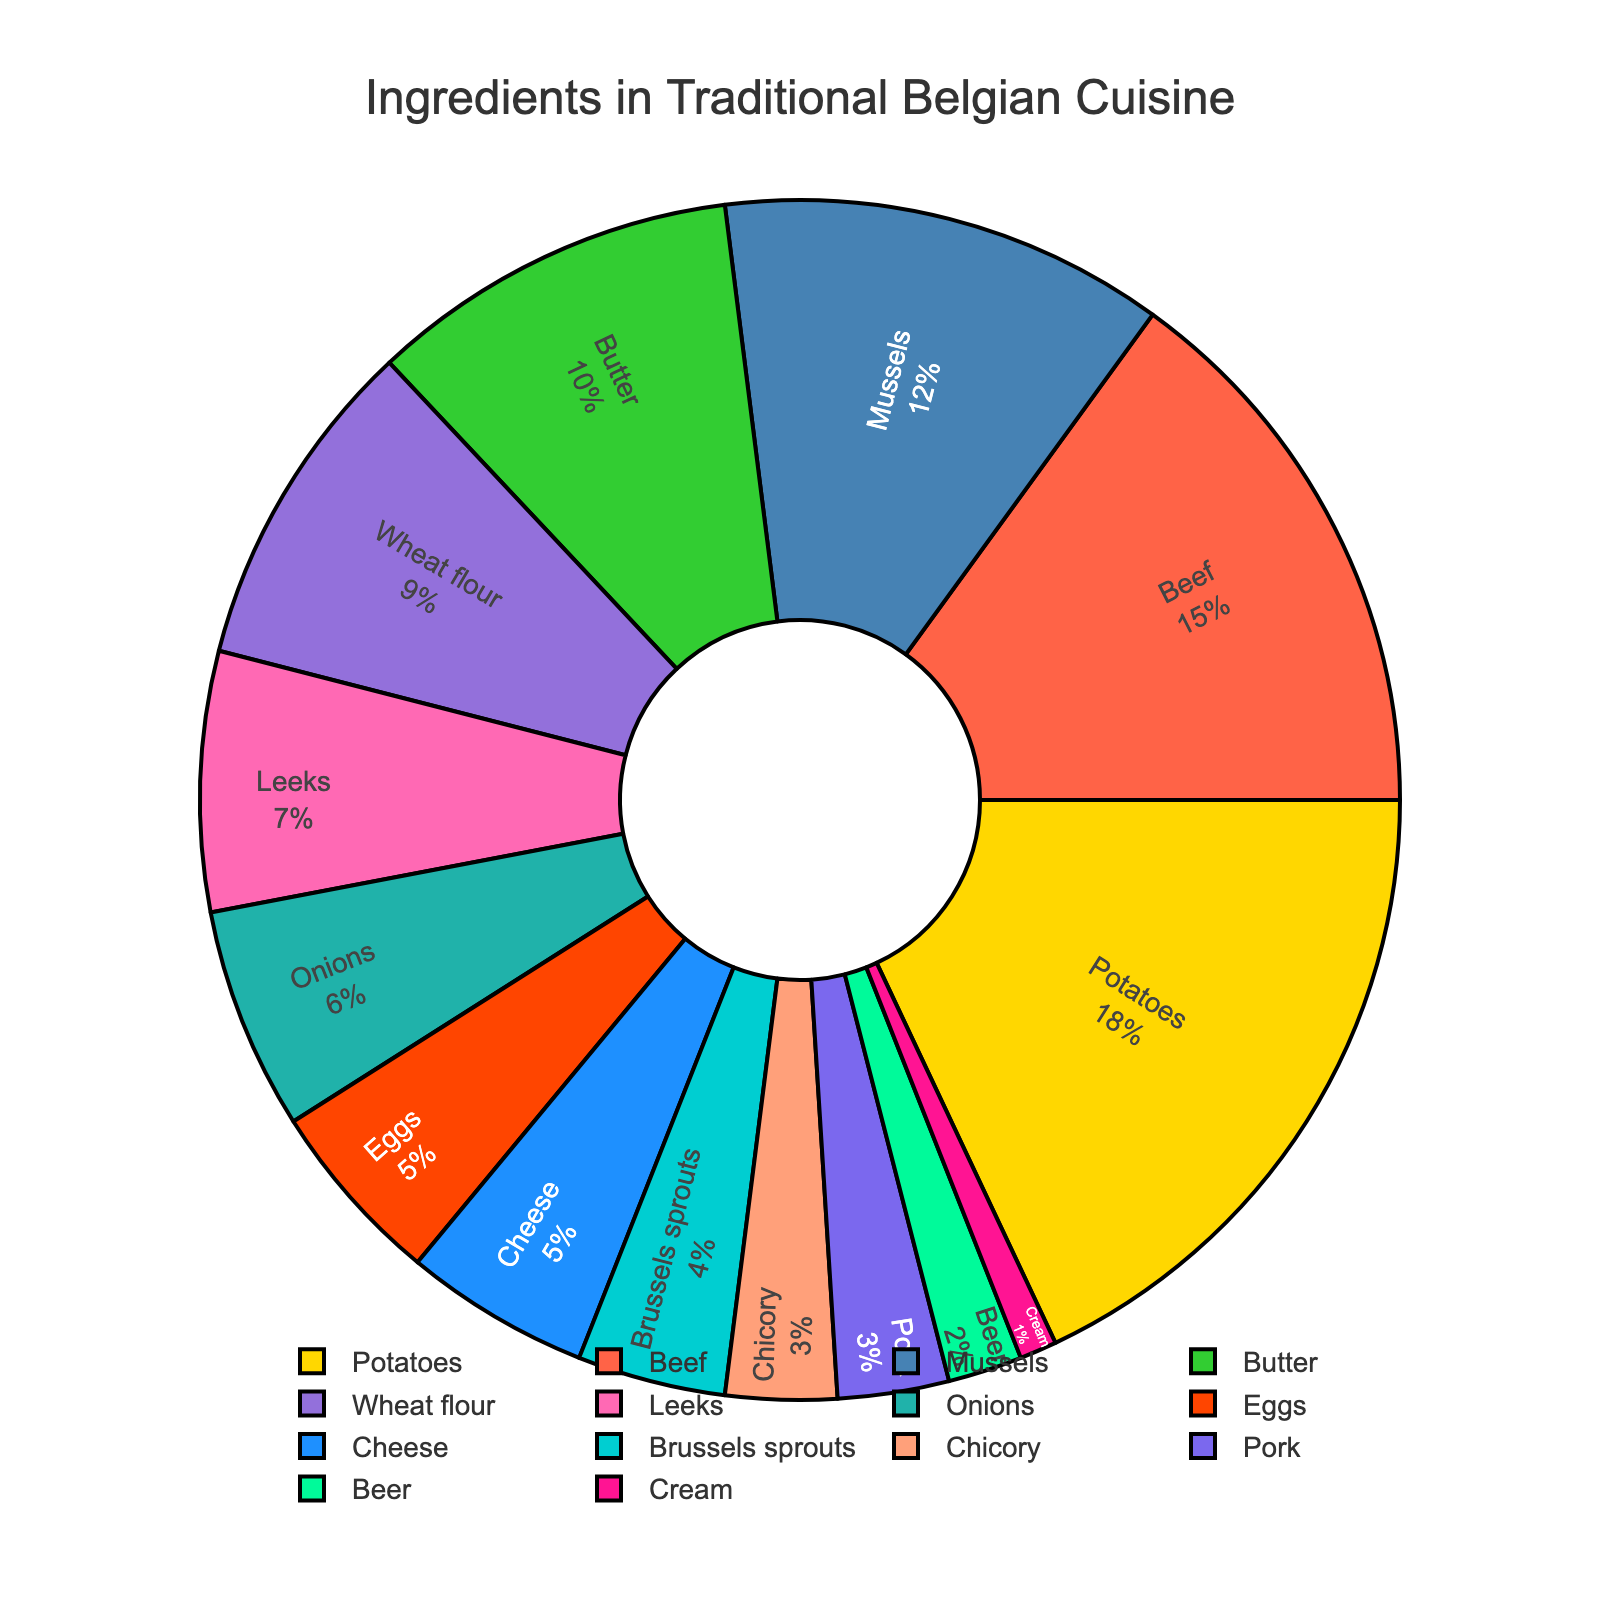Which ingredient is used the most in traditional Belgian cuisine? The largest portion in the pie chart represents potatoes with 18%.
Answer: Potatoes Which two ingredients together make up more than 30% of the traditional Belgian cuisine ingredients? Potatoes and beef together make up 18% + 15% = 33%.
Answer: Potatoes and Beef What is the combined percentage of butter, wheat flour, and leeks? Add the percentages of butter (10%), wheat flour (9%), and leeks (7%): 10% + 9% + 7% = 26%.
Answer: 26% Which ingredient constitutes a larger proportion, mussels or pork? By how much? Mussels make up 12% and pork makes up 3%. The difference is 12% - 3% = 9%.
Answer: Mussels by 9% Is there an equal percentage of any two ingredients? If yes, name them. Yes, both eggs and cheese each make up 5%.
Answer: Eggs and Cheese Which ingredient takes up the least percentage on the pie chart? Cream is the smallest at 1%.
Answer: Cream How does the percentage of onions compare to Brussels sprouts? Onions make up 6%, while Brussels sprouts make up 4%. Onions have a higher percentage.
Answer: Onions have a higher percentage What percentage do the top three ingredients together constitute? The top three are potatoes (18%), beef (15%), and mussels (12%). Together they make up 18% + 15% + 12% = 45%.
Answer: 45% Which ingredient, represented by a light blue color, is included in the chart? The light blue color represents onions, which make up 6% of the ingredients.
Answer: Onions Which ingredients make up less than 5% each? Brussels sprouts (4%), chicory (3%), pork (3%), beer (2%), and cream (1%) each account for less than 5%.
Answer: Brussels sprouts, chicory, pork, beer, and cream 